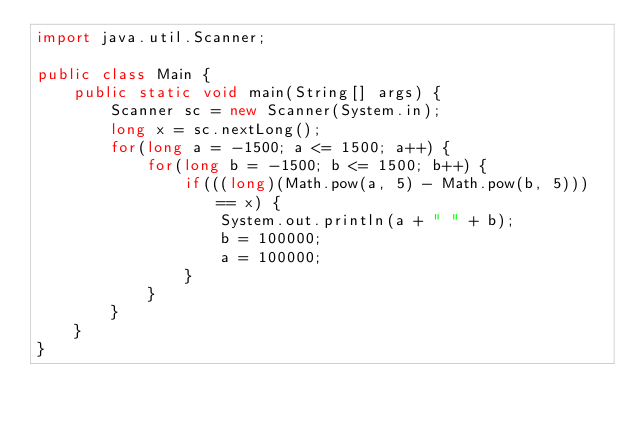Convert code to text. <code><loc_0><loc_0><loc_500><loc_500><_Java_>import java.util.Scanner;

public class Main {
    public static void main(String[] args) {
        Scanner sc = new Scanner(System.in);
        long x = sc.nextLong();
        for(long a = -1500; a <= 1500; a++) {
            for(long b = -1500; b <= 1500; b++) {
                if(((long)(Math.pow(a, 5) - Math.pow(b, 5))) == x) {
                    System.out.println(a + " " + b);
                    b = 100000;
                    a = 100000;
                }
            }
        }
    }
}
</code> 